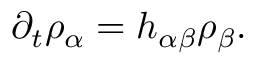<formula> <loc_0><loc_0><loc_500><loc_500>\partial _ { t } \rho _ { \alpha } = h _ { \alpha \beta } \rho _ { \beta } .</formula> 